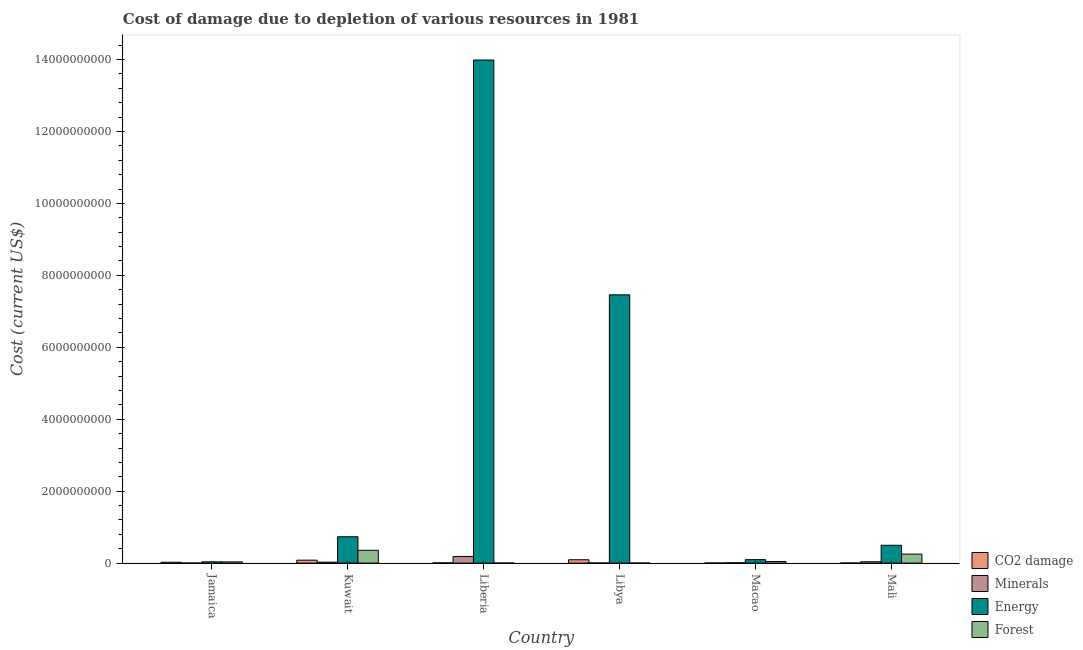How many different coloured bars are there?
Give a very brief answer. 4. How many groups of bars are there?
Offer a terse response. 6. Are the number of bars per tick equal to the number of legend labels?
Give a very brief answer. Yes. Are the number of bars on each tick of the X-axis equal?
Provide a succinct answer. Yes. How many bars are there on the 2nd tick from the right?
Your answer should be very brief. 4. What is the label of the 5th group of bars from the left?
Provide a succinct answer. Macao. In how many cases, is the number of bars for a given country not equal to the number of legend labels?
Your answer should be very brief. 0. What is the cost of damage due to depletion of coal in Mali?
Offer a terse response. 1.28e+06. Across all countries, what is the maximum cost of damage due to depletion of minerals?
Your response must be concise. 1.85e+08. Across all countries, what is the minimum cost of damage due to depletion of coal?
Give a very brief answer. 1.28e+06. In which country was the cost of damage due to depletion of coal maximum?
Your answer should be very brief. Libya. In which country was the cost of damage due to depletion of forests minimum?
Give a very brief answer. Liberia. What is the total cost of damage due to depletion of forests in the graph?
Provide a short and direct response. 6.86e+08. What is the difference between the cost of damage due to depletion of forests in Macao and that in Mali?
Offer a very short reply. -2.06e+08. What is the difference between the cost of damage due to depletion of forests in Liberia and the cost of damage due to depletion of energy in Mali?
Ensure brevity in your answer.  -4.95e+08. What is the average cost of damage due to depletion of coal per country?
Provide a short and direct response. 3.46e+07. What is the difference between the cost of damage due to depletion of energy and cost of damage due to depletion of forests in Libya?
Provide a succinct answer. 7.46e+09. What is the ratio of the cost of damage due to depletion of energy in Macao to that in Mali?
Your response must be concise. 0.19. Is the cost of damage due to depletion of coal in Libya less than that in Macao?
Give a very brief answer. No. Is the difference between the cost of damage due to depletion of coal in Macao and Mali greater than the difference between the cost of damage due to depletion of minerals in Macao and Mali?
Offer a very short reply. Yes. What is the difference between the highest and the second highest cost of damage due to depletion of coal?
Your answer should be very brief. 1.16e+07. What is the difference between the highest and the lowest cost of damage due to depletion of energy?
Offer a very short reply. 1.40e+1. In how many countries, is the cost of damage due to depletion of forests greater than the average cost of damage due to depletion of forests taken over all countries?
Provide a succinct answer. 2. What does the 3rd bar from the left in Kuwait represents?
Give a very brief answer. Energy. What does the 3rd bar from the right in Kuwait represents?
Keep it short and to the point. Minerals. How many bars are there?
Your answer should be compact. 24. How many countries are there in the graph?
Make the answer very short. 6. Are the values on the major ticks of Y-axis written in scientific E-notation?
Your answer should be compact. No. Does the graph contain grids?
Offer a terse response. No. Where does the legend appear in the graph?
Provide a short and direct response. Bottom right. How many legend labels are there?
Offer a terse response. 4. What is the title of the graph?
Your answer should be compact. Cost of damage due to depletion of various resources in 1981 . Does "Quality of public administration" appear as one of the legend labels in the graph?
Your response must be concise. No. What is the label or title of the Y-axis?
Your answer should be very brief. Cost (current US$). What is the Cost (current US$) of CO2 damage in Jamaica?
Your response must be concise. 2.40e+07. What is the Cost (current US$) in Minerals in Jamaica?
Give a very brief answer. 4.74e+05. What is the Cost (current US$) in Energy in Jamaica?
Give a very brief answer. 3.45e+07. What is the Cost (current US$) of Forest in Jamaica?
Your answer should be compact. 3.38e+07. What is the Cost (current US$) of CO2 damage in Kuwait?
Keep it short and to the point. 8.15e+07. What is the Cost (current US$) in Minerals in Kuwait?
Keep it short and to the point. 2.65e+07. What is the Cost (current US$) in Energy in Kuwait?
Provide a short and direct response. 7.32e+08. What is the Cost (current US$) in Forest in Kuwait?
Your answer should be compact. 3.56e+08. What is the Cost (current US$) of CO2 damage in Liberia?
Provide a succinct answer. 6.27e+06. What is the Cost (current US$) in Minerals in Liberia?
Ensure brevity in your answer.  1.85e+08. What is the Cost (current US$) of Energy in Liberia?
Provide a succinct answer. 1.40e+1. What is the Cost (current US$) of Forest in Liberia?
Give a very brief answer. 5.37e+05. What is the Cost (current US$) in CO2 damage in Libya?
Your answer should be very brief. 9.31e+07. What is the Cost (current US$) of Minerals in Libya?
Provide a short and direct response. 3.36e+06. What is the Cost (current US$) in Energy in Libya?
Offer a terse response. 7.46e+09. What is the Cost (current US$) in Forest in Libya?
Your response must be concise. 8.99e+05. What is the Cost (current US$) in CO2 damage in Macao?
Keep it short and to the point. 1.73e+06. What is the Cost (current US$) in Minerals in Macao?
Give a very brief answer. 7.45e+06. What is the Cost (current US$) of Energy in Macao?
Give a very brief answer. 9.61e+07. What is the Cost (current US$) in Forest in Macao?
Your response must be concise. 4.39e+07. What is the Cost (current US$) in CO2 damage in Mali?
Keep it short and to the point. 1.28e+06. What is the Cost (current US$) in Minerals in Mali?
Ensure brevity in your answer.  3.74e+07. What is the Cost (current US$) of Energy in Mali?
Provide a succinct answer. 4.96e+08. What is the Cost (current US$) of Forest in Mali?
Your response must be concise. 2.50e+08. Across all countries, what is the maximum Cost (current US$) of CO2 damage?
Make the answer very short. 9.31e+07. Across all countries, what is the maximum Cost (current US$) in Minerals?
Give a very brief answer. 1.85e+08. Across all countries, what is the maximum Cost (current US$) of Energy?
Provide a succinct answer. 1.40e+1. Across all countries, what is the maximum Cost (current US$) in Forest?
Your answer should be compact. 3.56e+08. Across all countries, what is the minimum Cost (current US$) of CO2 damage?
Your answer should be compact. 1.28e+06. Across all countries, what is the minimum Cost (current US$) of Minerals?
Make the answer very short. 4.74e+05. Across all countries, what is the minimum Cost (current US$) in Energy?
Provide a succinct answer. 3.45e+07. Across all countries, what is the minimum Cost (current US$) in Forest?
Your answer should be compact. 5.37e+05. What is the total Cost (current US$) of CO2 damage in the graph?
Make the answer very short. 2.08e+08. What is the total Cost (current US$) of Minerals in the graph?
Offer a terse response. 2.60e+08. What is the total Cost (current US$) in Energy in the graph?
Provide a short and direct response. 2.28e+1. What is the total Cost (current US$) of Forest in the graph?
Give a very brief answer. 6.86e+08. What is the difference between the Cost (current US$) of CO2 damage in Jamaica and that in Kuwait?
Your answer should be very brief. -5.75e+07. What is the difference between the Cost (current US$) in Minerals in Jamaica and that in Kuwait?
Offer a terse response. -2.60e+07. What is the difference between the Cost (current US$) in Energy in Jamaica and that in Kuwait?
Provide a succinct answer. -6.98e+08. What is the difference between the Cost (current US$) in Forest in Jamaica and that in Kuwait?
Provide a succinct answer. -3.22e+08. What is the difference between the Cost (current US$) in CO2 damage in Jamaica and that in Liberia?
Offer a very short reply. 1.77e+07. What is the difference between the Cost (current US$) of Minerals in Jamaica and that in Liberia?
Offer a terse response. -1.84e+08. What is the difference between the Cost (current US$) of Energy in Jamaica and that in Liberia?
Your answer should be very brief. -1.40e+1. What is the difference between the Cost (current US$) of Forest in Jamaica and that in Liberia?
Provide a succinct answer. 3.33e+07. What is the difference between the Cost (current US$) in CO2 damage in Jamaica and that in Libya?
Give a very brief answer. -6.92e+07. What is the difference between the Cost (current US$) in Minerals in Jamaica and that in Libya?
Provide a short and direct response. -2.89e+06. What is the difference between the Cost (current US$) of Energy in Jamaica and that in Libya?
Provide a short and direct response. -7.42e+09. What is the difference between the Cost (current US$) of Forest in Jamaica and that in Libya?
Your answer should be very brief. 3.29e+07. What is the difference between the Cost (current US$) of CO2 damage in Jamaica and that in Macao?
Your answer should be compact. 2.22e+07. What is the difference between the Cost (current US$) in Minerals in Jamaica and that in Macao?
Your answer should be compact. -6.98e+06. What is the difference between the Cost (current US$) of Energy in Jamaica and that in Macao?
Keep it short and to the point. -6.16e+07. What is the difference between the Cost (current US$) in Forest in Jamaica and that in Macao?
Provide a short and direct response. -1.01e+07. What is the difference between the Cost (current US$) of CO2 damage in Jamaica and that in Mali?
Give a very brief answer. 2.27e+07. What is the difference between the Cost (current US$) of Minerals in Jamaica and that in Mali?
Your answer should be very brief. -3.69e+07. What is the difference between the Cost (current US$) of Energy in Jamaica and that in Mali?
Your response must be concise. -4.61e+08. What is the difference between the Cost (current US$) of Forest in Jamaica and that in Mali?
Give a very brief answer. -2.16e+08. What is the difference between the Cost (current US$) in CO2 damage in Kuwait and that in Liberia?
Offer a terse response. 7.52e+07. What is the difference between the Cost (current US$) of Minerals in Kuwait and that in Liberia?
Provide a succinct answer. -1.58e+08. What is the difference between the Cost (current US$) of Energy in Kuwait and that in Liberia?
Keep it short and to the point. -1.33e+1. What is the difference between the Cost (current US$) in Forest in Kuwait and that in Liberia?
Give a very brief answer. 3.56e+08. What is the difference between the Cost (current US$) in CO2 damage in Kuwait and that in Libya?
Offer a very short reply. -1.16e+07. What is the difference between the Cost (current US$) of Minerals in Kuwait and that in Libya?
Provide a short and direct response. 2.31e+07. What is the difference between the Cost (current US$) in Energy in Kuwait and that in Libya?
Provide a succinct answer. -6.73e+09. What is the difference between the Cost (current US$) in Forest in Kuwait and that in Libya?
Make the answer very short. 3.55e+08. What is the difference between the Cost (current US$) of CO2 damage in Kuwait and that in Macao?
Offer a very short reply. 7.98e+07. What is the difference between the Cost (current US$) of Minerals in Kuwait and that in Macao?
Give a very brief answer. 1.91e+07. What is the difference between the Cost (current US$) in Energy in Kuwait and that in Macao?
Ensure brevity in your answer.  6.36e+08. What is the difference between the Cost (current US$) of Forest in Kuwait and that in Macao?
Provide a short and direct response. 3.12e+08. What is the difference between the Cost (current US$) in CO2 damage in Kuwait and that in Mali?
Your answer should be compact. 8.02e+07. What is the difference between the Cost (current US$) of Minerals in Kuwait and that in Mali?
Your response must be concise. -1.09e+07. What is the difference between the Cost (current US$) of Energy in Kuwait and that in Mali?
Give a very brief answer. 2.37e+08. What is the difference between the Cost (current US$) of Forest in Kuwait and that in Mali?
Your answer should be very brief. 1.06e+08. What is the difference between the Cost (current US$) in CO2 damage in Liberia and that in Libya?
Your answer should be very brief. -8.69e+07. What is the difference between the Cost (current US$) of Minerals in Liberia and that in Libya?
Offer a very short reply. 1.81e+08. What is the difference between the Cost (current US$) of Energy in Liberia and that in Libya?
Give a very brief answer. 6.53e+09. What is the difference between the Cost (current US$) of Forest in Liberia and that in Libya?
Your answer should be compact. -3.62e+05. What is the difference between the Cost (current US$) of CO2 damage in Liberia and that in Macao?
Make the answer very short. 4.54e+06. What is the difference between the Cost (current US$) in Minerals in Liberia and that in Macao?
Keep it short and to the point. 1.77e+08. What is the difference between the Cost (current US$) in Energy in Liberia and that in Macao?
Your response must be concise. 1.39e+1. What is the difference between the Cost (current US$) of Forest in Liberia and that in Macao?
Ensure brevity in your answer.  -4.34e+07. What is the difference between the Cost (current US$) in CO2 damage in Liberia and that in Mali?
Make the answer very short. 4.99e+06. What is the difference between the Cost (current US$) of Minerals in Liberia and that in Mali?
Make the answer very short. 1.47e+08. What is the difference between the Cost (current US$) in Energy in Liberia and that in Mali?
Offer a terse response. 1.35e+1. What is the difference between the Cost (current US$) of Forest in Liberia and that in Mali?
Provide a short and direct response. -2.50e+08. What is the difference between the Cost (current US$) of CO2 damage in Libya and that in Macao?
Your response must be concise. 9.14e+07. What is the difference between the Cost (current US$) in Minerals in Libya and that in Macao?
Your answer should be very brief. -4.09e+06. What is the difference between the Cost (current US$) of Energy in Libya and that in Macao?
Your response must be concise. 7.36e+09. What is the difference between the Cost (current US$) in Forest in Libya and that in Macao?
Keep it short and to the point. -4.30e+07. What is the difference between the Cost (current US$) of CO2 damage in Libya and that in Mali?
Your answer should be very brief. 9.18e+07. What is the difference between the Cost (current US$) of Minerals in Libya and that in Mali?
Provide a succinct answer. -3.40e+07. What is the difference between the Cost (current US$) in Energy in Libya and that in Mali?
Give a very brief answer. 6.96e+09. What is the difference between the Cost (current US$) in Forest in Libya and that in Mali?
Your answer should be compact. -2.49e+08. What is the difference between the Cost (current US$) in CO2 damage in Macao and that in Mali?
Make the answer very short. 4.50e+05. What is the difference between the Cost (current US$) of Minerals in Macao and that in Mali?
Your answer should be compact. -2.99e+07. What is the difference between the Cost (current US$) of Energy in Macao and that in Mali?
Your answer should be compact. -4.00e+08. What is the difference between the Cost (current US$) in Forest in Macao and that in Mali?
Offer a terse response. -2.06e+08. What is the difference between the Cost (current US$) of CO2 damage in Jamaica and the Cost (current US$) of Minerals in Kuwait?
Your answer should be very brief. -2.55e+06. What is the difference between the Cost (current US$) of CO2 damage in Jamaica and the Cost (current US$) of Energy in Kuwait?
Offer a very short reply. -7.08e+08. What is the difference between the Cost (current US$) in CO2 damage in Jamaica and the Cost (current US$) in Forest in Kuwait?
Your answer should be compact. -3.32e+08. What is the difference between the Cost (current US$) of Minerals in Jamaica and the Cost (current US$) of Energy in Kuwait?
Provide a succinct answer. -7.32e+08. What is the difference between the Cost (current US$) of Minerals in Jamaica and the Cost (current US$) of Forest in Kuwait?
Keep it short and to the point. -3.56e+08. What is the difference between the Cost (current US$) of Energy in Jamaica and the Cost (current US$) of Forest in Kuwait?
Your response must be concise. -3.22e+08. What is the difference between the Cost (current US$) of CO2 damage in Jamaica and the Cost (current US$) of Minerals in Liberia?
Ensure brevity in your answer.  -1.61e+08. What is the difference between the Cost (current US$) in CO2 damage in Jamaica and the Cost (current US$) in Energy in Liberia?
Make the answer very short. -1.40e+1. What is the difference between the Cost (current US$) in CO2 damage in Jamaica and the Cost (current US$) in Forest in Liberia?
Ensure brevity in your answer.  2.34e+07. What is the difference between the Cost (current US$) of Minerals in Jamaica and the Cost (current US$) of Energy in Liberia?
Give a very brief answer. -1.40e+1. What is the difference between the Cost (current US$) of Minerals in Jamaica and the Cost (current US$) of Forest in Liberia?
Provide a succinct answer. -6.34e+04. What is the difference between the Cost (current US$) in Energy in Jamaica and the Cost (current US$) in Forest in Liberia?
Ensure brevity in your answer.  3.40e+07. What is the difference between the Cost (current US$) in CO2 damage in Jamaica and the Cost (current US$) in Minerals in Libya?
Your answer should be compact. 2.06e+07. What is the difference between the Cost (current US$) in CO2 damage in Jamaica and the Cost (current US$) in Energy in Libya?
Ensure brevity in your answer.  -7.43e+09. What is the difference between the Cost (current US$) of CO2 damage in Jamaica and the Cost (current US$) of Forest in Libya?
Your answer should be very brief. 2.31e+07. What is the difference between the Cost (current US$) of Minerals in Jamaica and the Cost (current US$) of Energy in Libya?
Provide a short and direct response. -7.46e+09. What is the difference between the Cost (current US$) in Minerals in Jamaica and the Cost (current US$) in Forest in Libya?
Your answer should be compact. -4.25e+05. What is the difference between the Cost (current US$) of Energy in Jamaica and the Cost (current US$) of Forest in Libya?
Offer a terse response. 3.36e+07. What is the difference between the Cost (current US$) in CO2 damage in Jamaica and the Cost (current US$) in Minerals in Macao?
Make the answer very short. 1.65e+07. What is the difference between the Cost (current US$) in CO2 damage in Jamaica and the Cost (current US$) in Energy in Macao?
Your answer should be very brief. -7.21e+07. What is the difference between the Cost (current US$) of CO2 damage in Jamaica and the Cost (current US$) of Forest in Macao?
Your answer should be very brief. -2.00e+07. What is the difference between the Cost (current US$) in Minerals in Jamaica and the Cost (current US$) in Energy in Macao?
Your answer should be very brief. -9.56e+07. What is the difference between the Cost (current US$) of Minerals in Jamaica and the Cost (current US$) of Forest in Macao?
Your response must be concise. -4.35e+07. What is the difference between the Cost (current US$) in Energy in Jamaica and the Cost (current US$) in Forest in Macao?
Give a very brief answer. -9.45e+06. What is the difference between the Cost (current US$) in CO2 damage in Jamaica and the Cost (current US$) in Minerals in Mali?
Your response must be concise. -1.34e+07. What is the difference between the Cost (current US$) in CO2 damage in Jamaica and the Cost (current US$) in Energy in Mali?
Your answer should be very brief. -4.72e+08. What is the difference between the Cost (current US$) of CO2 damage in Jamaica and the Cost (current US$) of Forest in Mali?
Provide a short and direct response. -2.26e+08. What is the difference between the Cost (current US$) of Minerals in Jamaica and the Cost (current US$) of Energy in Mali?
Your answer should be very brief. -4.95e+08. What is the difference between the Cost (current US$) in Minerals in Jamaica and the Cost (current US$) in Forest in Mali?
Provide a short and direct response. -2.50e+08. What is the difference between the Cost (current US$) in Energy in Jamaica and the Cost (current US$) in Forest in Mali?
Provide a short and direct response. -2.16e+08. What is the difference between the Cost (current US$) of CO2 damage in Kuwait and the Cost (current US$) of Minerals in Liberia?
Give a very brief answer. -1.03e+08. What is the difference between the Cost (current US$) in CO2 damage in Kuwait and the Cost (current US$) in Energy in Liberia?
Make the answer very short. -1.39e+1. What is the difference between the Cost (current US$) of CO2 damage in Kuwait and the Cost (current US$) of Forest in Liberia?
Give a very brief answer. 8.10e+07. What is the difference between the Cost (current US$) of Minerals in Kuwait and the Cost (current US$) of Energy in Liberia?
Ensure brevity in your answer.  -1.40e+1. What is the difference between the Cost (current US$) in Minerals in Kuwait and the Cost (current US$) in Forest in Liberia?
Your answer should be very brief. 2.60e+07. What is the difference between the Cost (current US$) of Energy in Kuwait and the Cost (current US$) of Forest in Liberia?
Ensure brevity in your answer.  7.32e+08. What is the difference between the Cost (current US$) of CO2 damage in Kuwait and the Cost (current US$) of Minerals in Libya?
Keep it short and to the point. 7.81e+07. What is the difference between the Cost (current US$) in CO2 damage in Kuwait and the Cost (current US$) in Energy in Libya?
Give a very brief answer. -7.38e+09. What is the difference between the Cost (current US$) in CO2 damage in Kuwait and the Cost (current US$) in Forest in Libya?
Your response must be concise. 8.06e+07. What is the difference between the Cost (current US$) of Minerals in Kuwait and the Cost (current US$) of Energy in Libya?
Make the answer very short. -7.43e+09. What is the difference between the Cost (current US$) in Minerals in Kuwait and the Cost (current US$) in Forest in Libya?
Give a very brief answer. 2.56e+07. What is the difference between the Cost (current US$) of Energy in Kuwait and the Cost (current US$) of Forest in Libya?
Your response must be concise. 7.31e+08. What is the difference between the Cost (current US$) in CO2 damage in Kuwait and the Cost (current US$) in Minerals in Macao?
Your response must be concise. 7.40e+07. What is the difference between the Cost (current US$) of CO2 damage in Kuwait and the Cost (current US$) of Energy in Macao?
Offer a very short reply. -1.46e+07. What is the difference between the Cost (current US$) of CO2 damage in Kuwait and the Cost (current US$) of Forest in Macao?
Provide a succinct answer. 3.76e+07. What is the difference between the Cost (current US$) in Minerals in Kuwait and the Cost (current US$) in Energy in Macao?
Make the answer very short. -6.95e+07. What is the difference between the Cost (current US$) in Minerals in Kuwait and the Cost (current US$) in Forest in Macao?
Your response must be concise. -1.74e+07. What is the difference between the Cost (current US$) in Energy in Kuwait and the Cost (current US$) in Forest in Macao?
Your answer should be very brief. 6.88e+08. What is the difference between the Cost (current US$) of CO2 damage in Kuwait and the Cost (current US$) of Minerals in Mali?
Your answer should be very brief. 4.41e+07. What is the difference between the Cost (current US$) of CO2 damage in Kuwait and the Cost (current US$) of Energy in Mali?
Keep it short and to the point. -4.14e+08. What is the difference between the Cost (current US$) in CO2 damage in Kuwait and the Cost (current US$) in Forest in Mali?
Provide a short and direct response. -1.69e+08. What is the difference between the Cost (current US$) in Minerals in Kuwait and the Cost (current US$) in Energy in Mali?
Give a very brief answer. -4.69e+08. What is the difference between the Cost (current US$) in Minerals in Kuwait and the Cost (current US$) in Forest in Mali?
Make the answer very short. -2.24e+08. What is the difference between the Cost (current US$) of Energy in Kuwait and the Cost (current US$) of Forest in Mali?
Your answer should be very brief. 4.82e+08. What is the difference between the Cost (current US$) in CO2 damage in Liberia and the Cost (current US$) in Minerals in Libya?
Your answer should be very brief. 2.91e+06. What is the difference between the Cost (current US$) of CO2 damage in Liberia and the Cost (current US$) of Energy in Libya?
Offer a terse response. -7.45e+09. What is the difference between the Cost (current US$) of CO2 damage in Liberia and the Cost (current US$) of Forest in Libya?
Your answer should be very brief. 5.37e+06. What is the difference between the Cost (current US$) of Minerals in Liberia and the Cost (current US$) of Energy in Libya?
Your answer should be compact. -7.27e+09. What is the difference between the Cost (current US$) of Minerals in Liberia and the Cost (current US$) of Forest in Libya?
Ensure brevity in your answer.  1.84e+08. What is the difference between the Cost (current US$) of Energy in Liberia and the Cost (current US$) of Forest in Libya?
Give a very brief answer. 1.40e+1. What is the difference between the Cost (current US$) of CO2 damage in Liberia and the Cost (current US$) of Minerals in Macao?
Ensure brevity in your answer.  -1.18e+06. What is the difference between the Cost (current US$) in CO2 damage in Liberia and the Cost (current US$) in Energy in Macao?
Make the answer very short. -8.98e+07. What is the difference between the Cost (current US$) in CO2 damage in Liberia and the Cost (current US$) in Forest in Macao?
Your answer should be very brief. -3.77e+07. What is the difference between the Cost (current US$) in Minerals in Liberia and the Cost (current US$) in Energy in Macao?
Your answer should be compact. 8.85e+07. What is the difference between the Cost (current US$) in Minerals in Liberia and the Cost (current US$) in Forest in Macao?
Make the answer very short. 1.41e+08. What is the difference between the Cost (current US$) in Energy in Liberia and the Cost (current US$) in Forest in Macao?
Provide a short and direct response. 1.39e+1. What is the difference between the Cost (current US$) in CO2 damage in Liberia and the Cost (current US$) in Minerals in Mali?
Provide a succinct answer. -3.11e+07. What is the difference between the Cost (current US$) in CO2 damage in Liberia and the Cost (current US$) in Energy in Mali?
Ensure brevity in your answer.  -4.89e+08. What is the difference between the Cost (current US$) of CO2 damage in Liberia and the Cost (current US$) of Forest in Mali?
Your answer should be compact. -2.44e+08. What is the difference between the Cost (current US$) of Minerals in Liberia and the Cost (current US$) of Energy in Mali?
Offer a terse response. -3.11e+08. What is the difference between the Cost (current US$) of Minerals in Liberia and the Cost (current US$) of Forest in Mali?
Your answer should be very brief. -6.57e+07. What is the difference between the Cost (current US$) in Energy in Liberia and the Cost (current US$) in Forest in Mali?
Offer a terse response. 1.37e+1. What is the difference between the Cost (current US$) in CO2 damage in Libya and the Cost (current US$) in Minerals in Macao?
Ensure brevity in your answer.  8.57e+07. What is the difference between the Cost (current US$) of CO2 damage in Libya and the Cost (current US$) of Energy in Macao?
Your response must be concise. -2.93e+06. What is the difference between the Cost (current US$) in CO2 damage in Libya and the Cost (current US$) in Forest in Macao?
Provide a short and direct response. 4.92e+07. What is the difference between the Cost (current US$) of Minerals in Libya and the Cost (current US$) of Energy in Macao?
Keep it short and to the point. -9.27e+07. What is the difference between the Cost (current US$) of Minerals in Libya and the Cost (current US$) of Forest in Macao?
Give a very brief answer. -4.06e+07. What is the difference between the Cost (current US$) of Energy in Libya and the Cost (current US$) of Forest in Macao?
Keep it short and to the point. 7.41e+09. What is the difference between the Cost (current US$) in CO2 damage in Libya and the Cost (current US$) in Minerals in Mali?
Offer a very short reply. 5.57e+07. What is the difference between the Cost (current US$) in CO2 damage in Libya and the Cost (current US$) in Energy in Mali?
Offer a terse response. -4.02e+08. What is the difference between the Cost (current US$) of CO2 damage in Libya and the Cost (current US$) of Forest in Mali?
Provide a succinct answer. -1.57e+08. What is the difference between the Cost (current US$) of Minerals in Libya and the Cost (current US$) of Energy in Mali?
Offer a terse response. -4.92e+08. What is the difference between the Cost (current US$) of Minerals in Libya and the Cost (current US$) of Forest in Mali?
Offer a very short reply. -2.47e+08. What is the difference between the Cost (current US$) in Energy in Libya and the Cost (current US$) in Forest in Mali?
Make the answer very short. 7.21e+09. What is the difference between the Cost (current US$) of CO2 damage in Macao and the Cost (current US$) of Minerals in Mali?
Provide a short and direct response. -3.57e+07. What is the difference between the Cost (current US$) of CO2 damage in Macao and the Cost (current US$) of Energy in Mali?
Offer a terse response. -4.94e+08. What is the difference between the Cost (current US$) of CO2 damage in Macao and the Cost (current US$) of Forest in Mali?
Make the answer very short. -2.48e+08. What is the difference between the Cost (current US$) in Minerals in Macao and the Cost (current US$) in Energy in Mali?
Your response must be concise. -4.88e+08. What is the difference between the Cost (current US$) of Minerals in Macao and the Cost (current US$) of Forest in Mali?
Ensure brevity in your answer.  -2.43e+08. What is the difference between the Cost (current US$) in Energy in Macao and the Cost (current US$) in Forest in Mali?
Give a very brief answer. -1.54e+08. What is the average Cost (current US$) in CO2 damage per country?
Your answer should be very brief. 3.46e+07. What is the average Cost (current US$) in Minerals per country?
Your response must be concise. 4.33e+07. What is the average Cost (current US$) in Energy per country?
Your answer should be compact. 3.80e+09. What is the average Cost (current US$) of Forest per country?
Make the answer very short. 1.14e+08. What is the difference between the Cost (current US$) in CO2 damage and Cost (current US$) in Minerals in Jamaica?
Offer a terse response. 2.35e+07. What is the difference between the Cost (current US$) of CO2 damage and Cost (current US$) of Energy in Jamaica?
Give a very brief answer. -1.05e+07. What is the difference between the Cost (current US$) of CO2 damage and Cost (current US$) of Forest in Jamaica?
Your response must be concise. -9.88e+06. What is the difference between the Cost (current US$) in Minerals and Cost (current US$) in Energy in Jamaica?
Provide a short and direct response. -3.40e+07. What is the difference between the Cost (current US$) in Minerals and Cost (current US$) in Forest in Jamaica?
Your answer should be compact. -3.34e+07. What is the difference between the Cost (current US$) of Energy and Cost (current US$) of Forest in Jamaica?
Provide a succinct answer. 6.52e+05. What is the difference between the Cost (current US$) in CO2 damage and Cost (current US$) in Minerals in Kuwait?
Keep it short and to the point. 5.50e+07. What is the difference between the Cost (current US$) of CO2 damage and Cost (current US$) of Energy in Kuwait?
Ensure brevity in your answer.  -6.51e+08. What is the difference between the Cost (current US$) in CO2 damage and Cost (current US$) in Forest in Kuwait?
Your answer should be very brief. -2.75e+08. What is the difference between the Cost (current US$) of Minerals and Cost (current US$) of Energy in Kuwait?
Ensure brevity in your answer.  -7.06e+08. What is the difference between the Cost (current US$) in Minerals and Cost (current US$) in Forest in Kuwait?
Offer a very short reply. -3.30e+08. What is the difference between the Cost (current US$) in Energy and Cost (current US$) in Forest in Kuwait?
Ensure brevity in your answer.  3.76e+08. What is the difference between the Cost (current US$) in CO2 damage and Cost (current US$) in Minerals in Liberia?
Your answer should be compact. -1.78e+08. What is the difference between the Cost (current US$) of CO2 damage and Cost (current US$) of Energy in Liberia?
Make the answer very short. -1.40e+1. What is the difference between the Cost (current US$) of CO2 damage and Cost (current US$) of Forest in Liberia?
Offer a terse response. 5.73e+06. What is the difference between the Cost (current US$) in Minerals and Cost (current US$) in Energy in Liberia?
Give a very brief answer. -1.38e+1. What is the difference between the Cost (current US$) of Minerals and Cost (current US$) of Forest in Liberia?
Give a very brief answer. 1.84e+08. What is the difference between the Cost (current US$) in Energy and Cost (current US$) in Forest in Liberia?
Offer a terse response. 1.40e+1. What is the difference between the Cost (current US$) in CO2 damage and Cost (current US$) in Minerals in Libya?
Your answer should be very brief. 8.98e+07. What is the difference between the Cost (current US$) in CO2 damage and Cost (current US$) in Energy in Libya?
Offer a terse response. -7.37e+09. What is the difference between the Cost (current US$) in CO2 damage and Cost (current US$) in Forest in Libya?
Offer a terse response. 9.22e+07. What is the difference between the Cost (current US$) of Minerals and Cost (current US$) of Energy in Libya?
Offer a very short reply. -7.46e+09. What is the difference between the Cost (current US$) of Minerals and Cost (current US$) of Forest in Libya?
Keep it short and to the point. 2.47e+06. What is the difference between the Cost (current US$) of Energy and Cost (current US$) of Forest in Libya?
Make the answer very short. 7.46e+09. What is the difference between the Cost (current US$) in CO2 damage and Cost (current US$) in Minerals in Macao?
Ensure brevity in your answer.  -5.72e+06. What is the difference between the Cost (current US$) in CO2 damage and Cost (current US$) in Energy in Macao?
Offer a terse response. -9.43e+07. What is the difference between the Cost (current US$) in CO2 damage and Cost (current US$) in Forest in Macao?
Provide a succinct answer. -4.22e+07. What is the difference between the Cost (current US$) in Minerals and Cost (current US$) in Energy in Macao?
Your response must be concise. -8.86e+07. What is the difference between the Cost (current US$) in Minerals and Cost (current US$) in Forest in Macao?
Make the answer very short. -3.65e+07. What is the difference between the Cost (current US$) in Energy and Cost (current US$) in Forest in Macao?
Give a very brief answer. 5.21e+07. What is the difference between the Cost (current US$) in CO2 damage and Cost (current US$) in Minerals in Mali?
Your answer should be very brief. -3.61e+07. What is the difference between the Cost (current US$) of CO2 damage and Cost (current US$) of Energy in Mali?
Make the answer very short. -4.94e+08. What is the difference between the Cost (current US$) of CO2 damage and Cost (current US$) of Forest in Mali?
Give a very brief answer. -2.49e+08. What is the difference between the Cost (current US$) in Minerals and Cost (current US$) in Energy in Mali?
Provide a succinct answer. -4.58e+08. What is the difference between the Cost (current US$) in Minerals and Cost (current US$) in Forest in Mali?
Make the answer very short. -2.13e+08. What is the difference between the Cost (current US$) in Energy and Cost (current US$) in Forest in Mali?
Keep it short and to the point. 2.45e+08. What is the ratio of the Cost (current US$) in CO2 damage in Jamaica to that in Kuwait?
Provide a succinct answer. 0.29. What is the ratio of the Cost (current US$) of Minerals in Jamaica to that in Kuwait?
Your answer should be compact. 0.02. What is the ratio of the Cost (current US$) of Energy in Jamaica to that in Kuwait?
Ensure brevity in your answer.  0.05. What is the ratio of the Cost (current US$) in Forest in Jamaica to that in Kuwait?
Give a very brief answer. 0.1. What is the ratio of the Cost (current US$) of CO2 damage in Jamaica to that in Liberia?
Your answer should be compact. 3.82. What is the ratio of the Cost (current US$) of Minerals in Jamaica to that in Liberia?
Provide a succinct answer. 0. What is the ratio of the Cost (current US$) of Energy in Jamaica to that in Liberia?
Provide a succinct answer. 0. What is the ratio of the Cost (current US$) in Forest in Jamaica to that in Liberia?
Your answer should be compact. 63.01. What is the ratio of the Cost (current US$) of CO2 damage in Jamaica to that in Libya?
Give a very brief answer. 0.26. What is the ratio of the Cost (current US$) of Minerals in Jamaica to that in Libya?
Ensure brevity in your answer.  0.14. What is the ratio of the Cost (current US$) in Energy in Jamaica to that in Libya?
Offer a terse response. 0. What is the ratio of the Cost (current US$) in Forest in Jamaica to that in Libya?
Your response must be concise. 37.64. What is the ratio of the Cost (current US$) in CO2 damage in Jamaica to that in Macao?
Provide a succinct answer. 13.85. What is the ratio of the Cost (current US$) in Minerals in Jamaica to that in Macao?
Make the answer very short. 0.06. What is the ratio of the Cost (current US$) in Energy in Jamaica to that in Macao?
Provide a short and direct response. 0.36. What is the ratio of the Cost (current US$) in Forest in Jamaica to that in Macao?
Offer a terse response. 0.77. What is the ratio of the Cost (current US$) in CO2 damage in Jamaica to that in Mali?
Offer a terse response. 18.72. What is the ratio of the Cost (current US$) of Minerals in Jamaica to that in Mali?
Provide a short and direct response. 0.01. What is the ratio of the Cost (current US$) of Energy in Jamaica to that in Mali?
Your answer should be compact. 0.07. What is the ratio of the Cost (current US$) in Forest in Jamaica to that in Mali?
Keep it short and to the point. 0.14. What is the ratio of the Cost (current US$) in CO2 damage in Kuwait to that in Liberia?
Your answer should be very brief. 13. What is the ratio of the Cost (current US$) in Minerals in Kuwait to that in Liberia?
Offer a very short reply. 0.14. What is the ratio of the Cost (current US$) in Energy in Kuwait to that in Liberia?
Your answer should be very brief. 0.05. What is the ratio of the Cost (current US$) in Forest in Kuwait to that in Liberia?
Give a very brief answer. 663.31. What is the ratio of the Cost (current US$) in CO2 damage in Kuwait to that in Libya?
Give a very brief answer. 0.88. What is the ratio of the Cost (current US$) in Minerals in Kuwait to that in Libya?
Keep it short and to the point. 7.88. What is the ratio of the Cost (current US$) in Energy in Kuwait to that in Libya?
Offer a terse response. 0.1. What is the ratio of the Cost (current US$) in Forest in Kuwait to that in Libya?
Keep it short and to the point. 396.28. What is the ratio of the Cost (current US$) in CO2 damage in Kuwait to that in Macao?
Your answer should be very brief. 47.1. What is the ratio of the Cost (current US$) of Minerals in Kuwait to that in Macao?
Ensure brevity in your answer.  3.56. What is the ratio of the Cost (current US$) in Energy in Kuwait to that in Macao?
Your answer should be compact. 7.62. What is the ratio of the Cost (current US$) of Forest in Kuwait to that in Macao?
Offer a very short reply. 8.11. What is the ratio of the Cost (current US$) in CO2 damage in Kuwait to that in Mali?
Ensure brevity in your answer.  63.67. What is the ratio of the Cost (current US$) in Minerals in Kuwait to that in Mali?
Give a very brief answer. 0.71. What is the ratio of the Cost (current US$) in Energy in Kuwait to that in Mali?
Ensure brevity in your answer.  1.48. What is the ratio of the Cost (current US$) of Forest in Kuwait to that in Mali?
Provide a succinct answer. 1.42. What is the ratio of the Cost (current US$) of CO2 damage in Liberia to that in Libya?
Your response must be concise. 0.07. What is the ratio of the Cost (current US$) of Minerals in Liberia to that in Libya?
Keep it short and to the point. 54.85. What is the ratio of the Cost (current US$) in Energy in Liberia to that in Libya?
Your answer should be very brief. 1.88. What is the ratio of the Cost (current US$) in Forest in Liberia to that in Libya?
Your response must be concise. 0.6. What is the ratio of the Cost (current US$) of CO2 damage in Liberia to that in Macao?
Ensure brevity in your answer.  3.62. What is the ratio of the Cost (current US$) of Minerals in Liberia to that in Macao?
Provide a succinct answer. 24.77. What is the ratio of the Cost (current US$) of Energy in Liberia to that in Macao?
Offer a terse response. 145.62. What is the ratio of the Cost (current US$) in Forest in Liberia to that in Macao?
Your answer should be very brief. 0.01. What is the ratio of the Cost (current US$) of CO2 damage in Liberia to that in Mali?
Keep it short and to the point. 4.9. What is the ratio of the Cost (current US$) in Minerals in Liberia to that in Mali?
Offer a very short reply. 4.94. What is the ratio of the Cost (current US$) of Energy in Liberia to that in Mali?
Your answer should be very brief. 28.22. What is the ratio of the Cost (current US$) in Forest in Liberia to that in Mali?
Make the answer very short. 0. What is the ratio of the Cost (current US$) in CO2 damage in Libya to that in Macao?
Make the answer very short. 53.82. What is the ratio of the Cost (current US$) in Minerals in Libya to that in Macao?
Give a very brief answer. 0.45. What is the ratio of the Cost (current US$) of Energy in Libya to that in Macao?
Offer a very short reply. 77.65. What is the ratio of the Cost (current US$) in Forest in Libya to that in Macao?
Your answer should be very brief. 0.02. What is the ratio of the Cost (current US$) of CO2 damage in Libya to that in Mali?
Your answer should be very brief. 72.75. What is the ratio of the Cost (current US$) of Minerals in Libya to that in Mali?
Keep it short and to the point. 0.09. What is the ratio of the Cost (current US$) of Energy in Libya to that in Mali?
Make the answer very short. 15.05. What is the ratio of the Cost (current US$) in Forest in Libya to that in Mali?
Keep it short and to the point. 0. What is the ratio of the Cost (current US$) in CO2 damage in Macao to that in Mali?
Provide a succinct answer. 1.35. What is the ratio of the Cost (current US$) in Minerals in Macao to that in Mali?
Your answer should be compact. 0.2. What is the ratio of the Cost (current US$) of Energy in Macao to that in Mali?
Offer a very short reply. 0.19. What is the ratio of the Cost (current US$) in Forest in Macao to that in Mali?
Ensure brevity in your answer.  0.18. What is the difference between the highest and the second highest Cost (current US$) of CO2 damage?
Your answer should be compact. 1.16e+07. What is the difference between the highest and the second highest Cost (current US$) of Minerals?
Your answer should be very brief. 1.47e+08. What is the difference between the highest and the second highest Cost (current US$) in Energy?
Offer a terse response. 6.53e+09. What is the difference between the highest and the second highest Cost (current US$) in Forest?
Your answer should be compact. 1.06e+08. What is the difference between the highest and the lowest Cost (current US$) in CO2 damage?
Provide a short and direct response. 9.18e+07. What is the difference between the highest and the lowest Cost (current US$) of Minerals?
Your answer should be compact. 1.84e+08. What is the difference between the highest and the lowest Cost (current US$) of Energy?
Offer a very short reply. 1.40e+1. What is the difference between the highest and the lowest Cost (current US$) in Forest?
Give a very brief answer. 3.56e+08. 